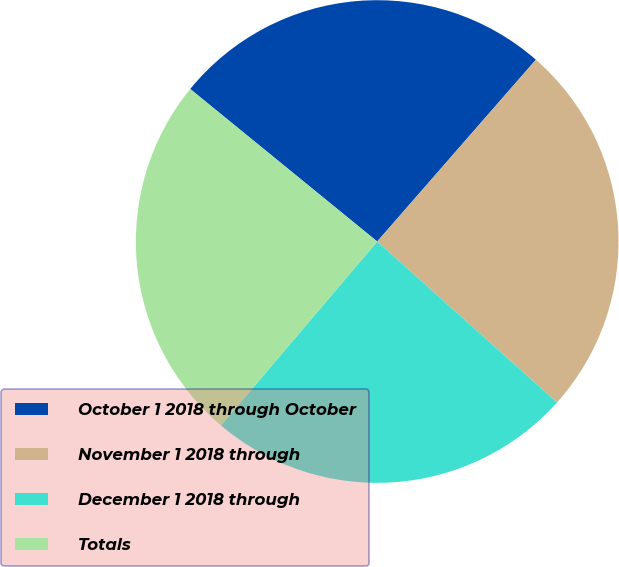Convert chart. <chart><loc_0><loc_0><loc_500><loc_500><pie_chart><fcel>October 1 2018 through October<fcel>November 1 2018 through<fcel>December 1 2018 through<fcel>Totals<nl><fcel>25.53%<fcel>25.2%<fcel>24.59%<fcel>24.68%<nl></chart> 